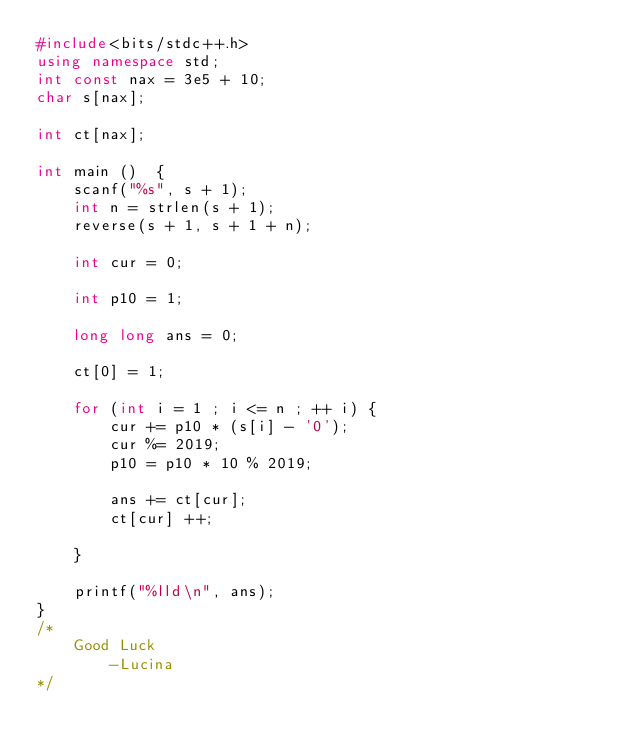<code> <loc_0><loc_0><loc_500><loc_500><_C++_>#include<bits/stdc++.h>
using namespace std;
int const nax = 3e5 + 10;
char s[nax];

int ct[nax];

int main ()  {
    scanf("%s", s + 1);
    int n = strlen(s + 1);
    reverse(s + 1, s + 1 + n);

    int cur = 0;

    int p10 = 1;

    long long ans = 0;

    ct[0] = 1;

    for (int i = 1 ; i <= n ; ++ i) {
        cur += p10 * (s[i] - '0');
        cur %= 2019;
        p10 = p10 * 10 % 2019;

        ans += ct[cur];
        ct[cur] ++;

    }

    printf("%lld\n", ans);
}
/*
    Good Luck
        -Lucina
*/
</code> 